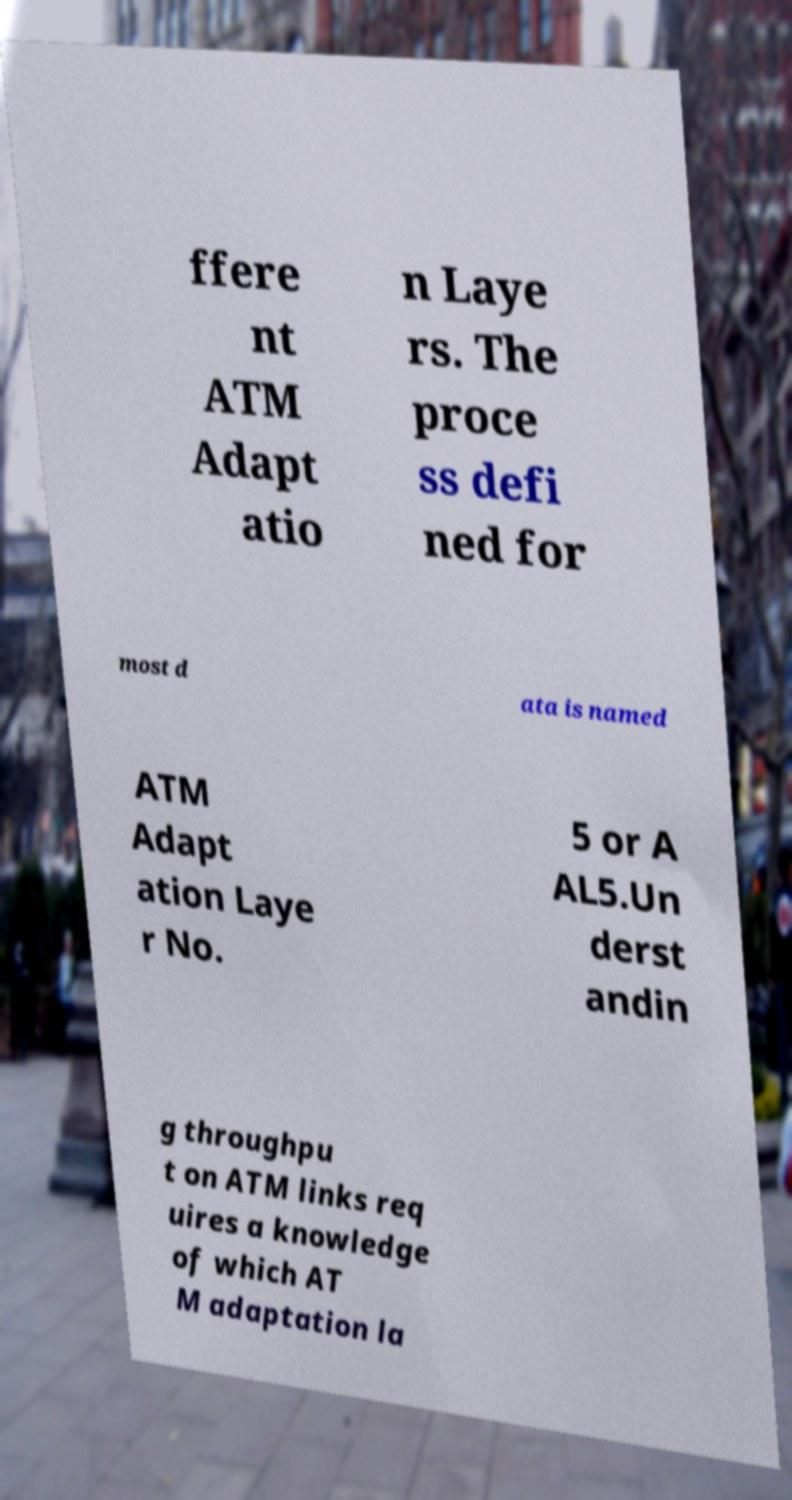I need the written content from this picture converted into text. Can you do that? ffere nt ATM Adapt atio n Laye rs. The proce ss defi ned for most d ata is named ATM Adapt ation Laye r No. 5 or A AL5.Un derst andin g throughpu t on ATM links req uires a knowledge of which AT M adaptation la 